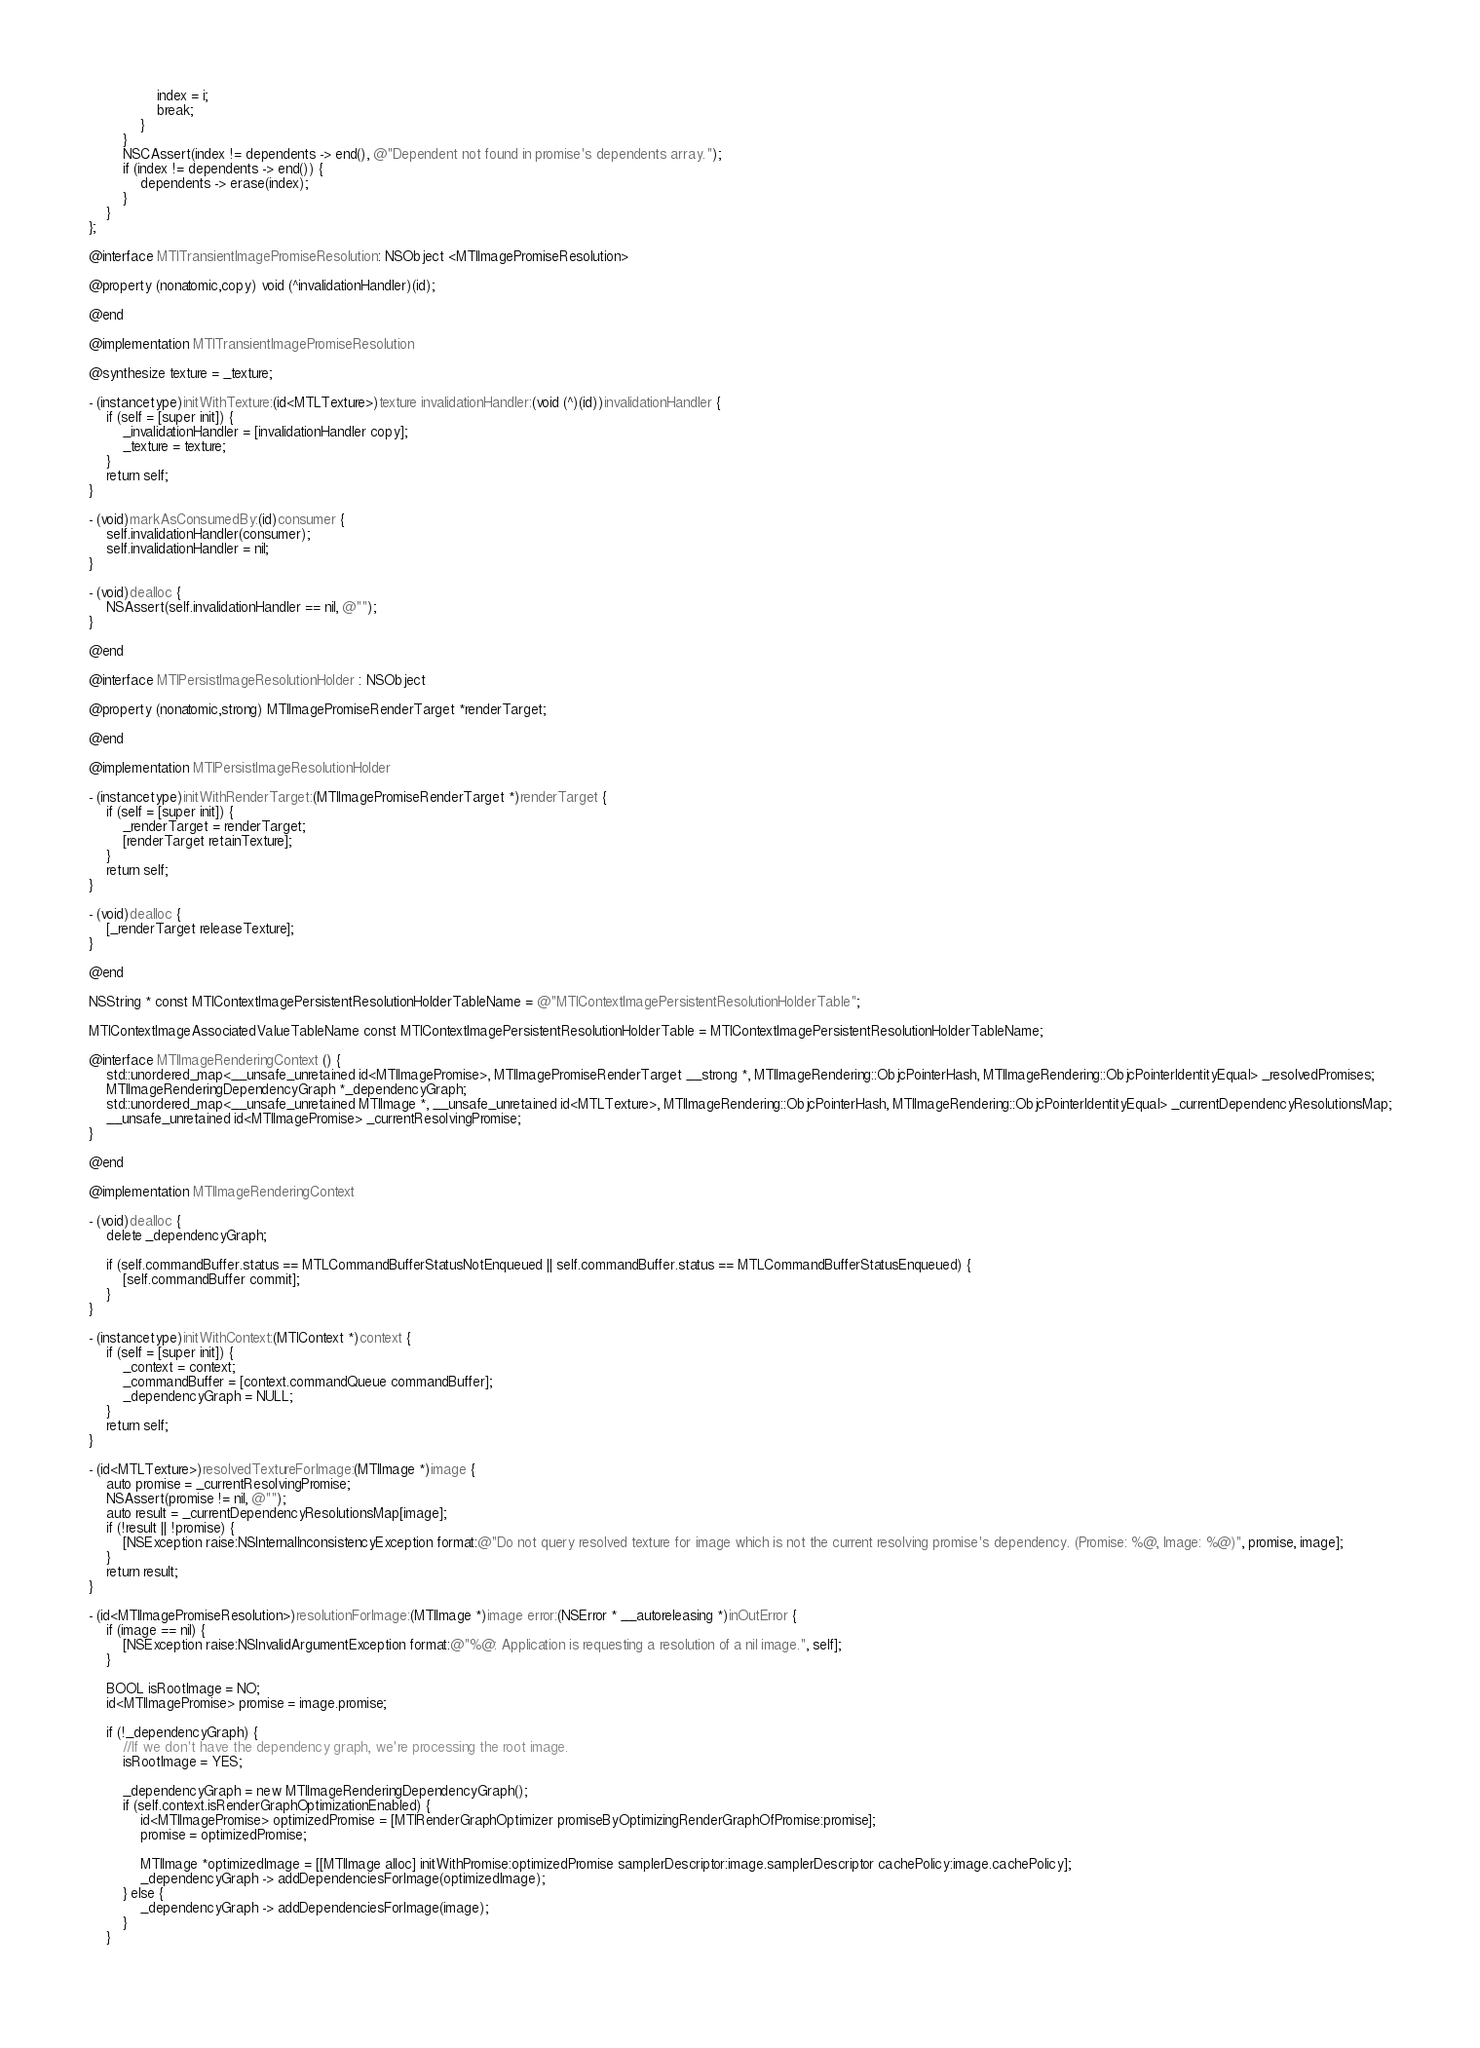<code> <loc_0><loc_0><loc_500><loc_500><_ObjectiveC_>                index = i;
                break;
            }
        }
        NSCAssert(index != dependents -> end(), @"Dependent not found in promise's dependents array.");
        if (index != dependents -> end()) {
            dependents -> erase(index);
        }
    }
};

@interface MTITransientImagePromiseResolution: NSObject <MTIImagePromiseResolution>

@property (nonatomic,copy) void (^invalidationHandler)(id);

@end

@implementation MTITransientImagePromiseResolution

@synthesize texture = _texture;

- (instancetype)initWithTexture:(id<MTLTexture>)texture invalidationHandler:(void (^)(id))invalidationHandler {
    if (self = [super init]) {
        _invalidationHandler = [invalidationHandler copy];
        _texture = texture;
    }
    return self;
}

- (void)markAsConsumedBy:(id)consumer {
    self.invalidationHandler(consumer);
    self.invalidationHandler = nil;
}

- (void)dealloc {
    NSAssert(self.invalidationHandler == nil, @"");
}

@end

@interface MTIPersistImageResolutionHolder : NSObject

@property (nonatomic,strong) MTIImagePromiseRenderTarget *renderTarget;

@end

@implementation MTIPersistImageResolutionHolder

- (instancetype)initWithRenderTarget:(MTIImagePromiseRenderTarget *)renderTarget {
    if (self = [super init]) {
        _renderTarget = renderTarget;
        [renderTarget retainTexture];
    }
    return self;
}

- (void)dealloc {
    [_renderTarget releaseTexture];
}

@end

NSString * const MTIContextImagePersistentResolutionHolderTableName = @"MTIContextImagePersistentResolutionHolderTable";

MTIContextImageAssociatedValueTableName const MTIContextImagePersistentResolutionHolderTable = MTIContextImagePersistentResolutionHolderTableName;

@interface MTIImageRenderingContext () {
    std::unordered_map<__unsafe_unretained id<MTIImagePromise>, MTIImagePromiseRenderTarget __strong *, MTIImageRendering::ObjcPointerHash, MTIImageRendering::ObjcPointerIdentityEqual> _resolvedPromises;
    MTIImageRenderingDependencyGraph *_dependencyGraph;
    std::unordered_map<__unsafe_unretained MTIImage *, __unsafe_unretained id<MTLTexture>, MTIImageRendering::ObjcPointerHash, MTIImageRendering::ObjcPointerIdentityEqual> _currentDependencyResolutionsMap;
    __unsafe_unretained id<MTIImagePromise> _currentResolvingPromise;
}

@end

@implementation MTIImageRenderingContext

- (void)dealloc {
    delete _dependencyGraph;
    
    if (self.commandBuffer.status == MTLCommandBufferStatusNotEnqueued || self.commandBuffer.status == MTLCommandBufferStatusEnqueued) {
        [self.commandBuffer commit];
    }
}

- (instancetype)initWithContext:(MTIContext *)context {
    if (self = [super init]) {
        _context = context;
        _commandBuffer = [context.commandQueue commandBuffer];
        _dependencyGraph = NULL;
    }
    return self;
}

- (id<MTLTexture>)resolvedTextureForImage:(MTIImage *)image {
    auto promise = _currentResolvingPromise;
    NSAssert(promise != nil, @"");
    auto result = _currentDependencyResolutionsMap[image];
    if (!result || !promise) {
        [NSException raise:NSInternalInconsistencyException format:@"Do not query resolved texture for image which is not the current resolving promise's dependency. (Promise: %@, Image: %@)", promise, image];
    }
    return result;
}

- (id<MTIImagePromiseResolution>)resolutionForImage:(MTIImage *)image error:(NSError * __autoreleasing *)inOutError {
    if (image == nil) {
        [NSException raise:NSInvalidArgumentException format:@"%@: Application is requesting a resolution of a nil image.", self];
    }
    
    BOOL isRootImage = NO;
    id<MTIImagePromise> promise = image.promise;
    
    if (!_dependencyGraph) {
        //If we don't have the dependency graph, we're processing the root image.
        isRootImage = YES;
        
        _dependencyGraph = new MTIImageRenderingDependencyGraph();
        if (self.context.isRenderGraphOptimizationEnabled) {
            id<MTIImagePromise> optimizedPromise = [MTIRenderGraphOptimizer promiseByOptimizingRenderGraphOfPromise:promise];
            promise = optimizedPromise;
            
            MTIImage *optimizedImage = [[MTIImage alloc] initWithPromise:optimizedPromise samplerDescriptor:image.samplerDescriptor cachePolicy:image.cachePolicy];
            _dependencyGraph -> addDependenciesForImage(optimizedImage);
        } else {
            _dependencyGraph -> addDependenciesForImage(image);
        }
    }
    </code> 